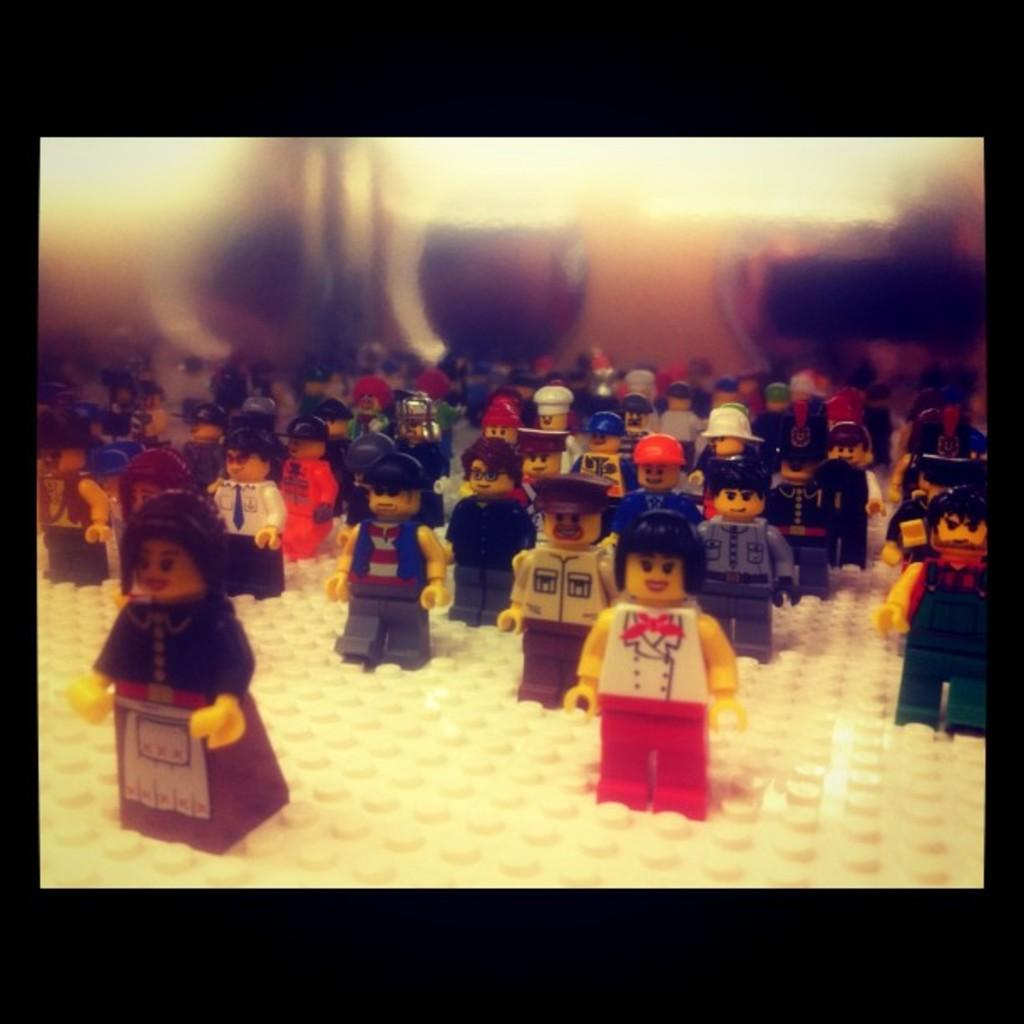What is the main subject of the image? The main subject of the image is many toys. What is the color of the surface on which the toys are placed? The toys are on a white surface. Can you describe the background of the image? The background of the image is blurred. What type of plantation can be seen in the background of the image? There is no plantation present in the image; the background is blurred. What team is responsible for organizing the toys in the image? There is no team involved in organizing the toys in the image; they are simply placed on the white surface. 